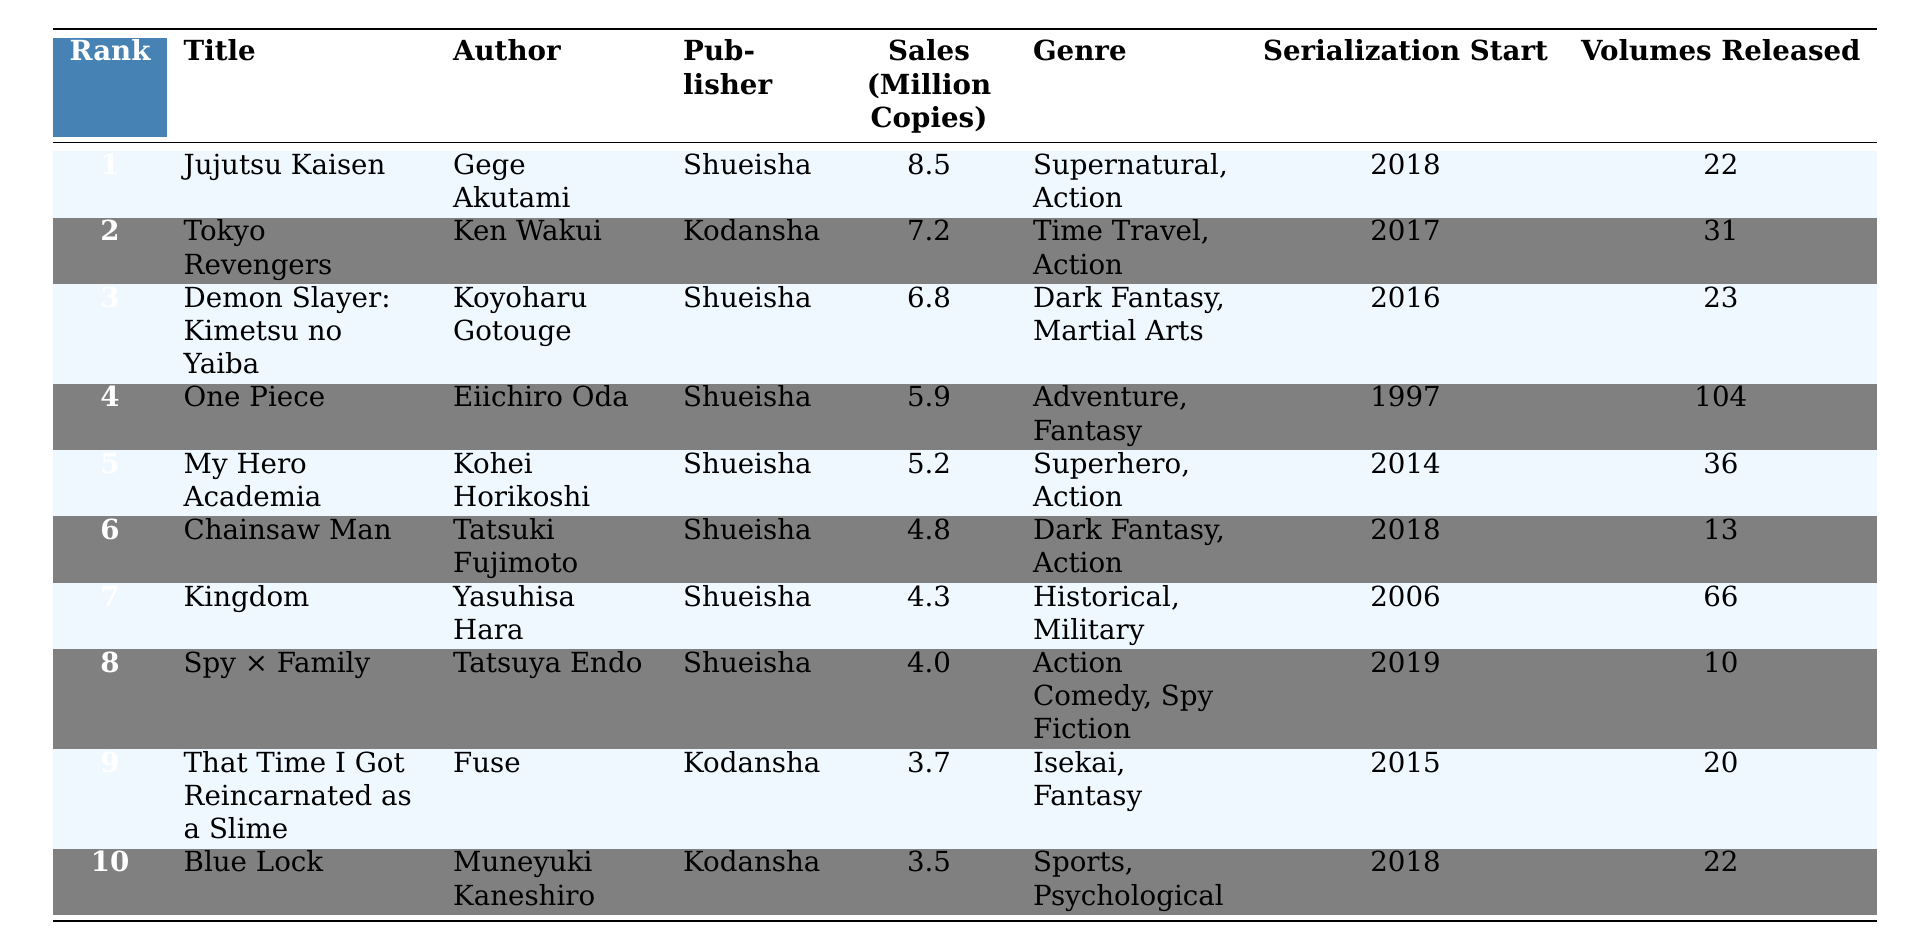What is the title of the best-selling manga in Japan for the past year? The best-selling manga is listed at rank 1, which is "Jujutsu Kaisen".
Answer: Jujutsu Kaisen Who is the author of "Demon Slayer: Kimetsu no Yaiba"? The author of the third-ranked manga "Demon Slayer: Kimetsu no Yaiba" is Koyoharu Gotouge.
Answer: Koyoharu Gotouge How many volumes have been released for "Spy × Family"? The table shows that "Spy × Family" has 10 volumes released, indicated in the last column.
Answer: 10 What is the total sales figure for the top three best-selling manga titles? The sales figures for the top three are 8.5 + 7.2 + 6.8 = 22.5 million copies combined.
Answer: 22.5 million copies Is "One Piece" published by Shueisha? Looking at the publisher column, "One Piece" is indeed published by Shueisha, confirming the statement.
Answer: Yes Which manga has a lower sales figure: "Blue Lock" or "Chainsaw Man"? "Blue Lock" sold 3.5 million copies and "Chainsaw Man" sold 4.8 million copies; therefore, "Blue Lock" has the lower sales figure.
Answer: Blue Lock How many more volumes are there in "My Hero Academia" than in "Chainsaw Man"? "My Hero Academia" has 36 volumes, while "Chainsaw Man" has 13 volumes. The difference is 36 - 13 = 23 volumes.
Answer: 23 volumes What is the genre of "Tokyo Revengers"? The genre listed for "Tokyo Revengers" is Time Travel, Action, found in the genre column.
Answer: Time Travel, Action Which author has the most titles in the top 10 list? All titles except "Tokyo Revengers" and "That Time I Got Reincarnated as a Slime" are authored by Gege Akutami, Kohei Horikoshi, Koyoharu Gotouge, and others from Shueisha; thus, Gege Akutami has one title in the list. 
However, the other authors (Tatsuki Fujimoto, Ken Wakui, etc.) have one each as well. This shows that no single author dominates.
Answer: None What percentage of the total sales does "Jujutsu Kaisen" account for among the top 10 titles? First, we sum up the sales: 8.5 + 7.2 + 6.8 + 5.9 + 5.2 + 4.8 + 4.3 + 4.0 + 3.7 + 3.5 = 54.9 million. Then, the percentage is calculated as (8.5 / 54.9) * 100 ≈ 15.5%.
Answer: 15.5% 